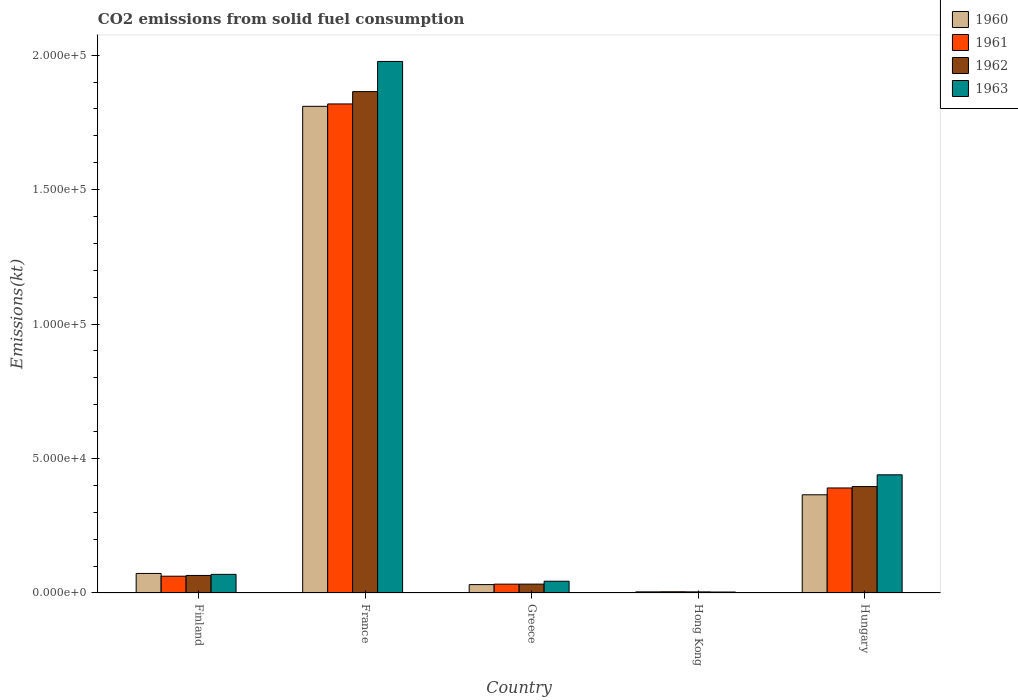How many different coloured bars are there?
Provide a short and direct response. 4. How many groups of bars are there?
Provide a succinct answer. 5. Are the number of bars per tick equal to the number of legend labels?
Make the answer very short. Yes. How many bars are there on the 1st tick from the left?
Your answer should be compact. 4. What is the amount of CO2 emitted in 1961 in Finland?
Ensure brevity in your answer.  6237.57. Across all countries, what is the maximum amount of CO2 emitted in 1960?
Offer a very short reply. 1.81e+05. Across all countries, what is the minimum amount of CO2 emitted in 1961?
Your answer should be very brief. 451.04. In which country was the amount of CO2 emitted in 1962 maximum?
Keep it short and to the point. France. In which country was the amount of CO2 emitted in 1962 minimum?
Your answer should be very brief. Hong Kong. What is the total amount of CO2 emitted in 1960 in the graph?
Offer a terse response. 2.28e+05. What is the difference between the amount of CO2 emitted in 1963 in Finland and that in Hungary?
Make the answer very short. -3.70e+04. What is the difference between the amount of CO2 emitted in 1960 in Greece and the amount of CO2 emitted in 1963 in Hong Kong?
Your answer should be very brief. 2761.25. What is the average amount of CO2 emitted in 1963 per country?
Give a very brief answer. 5.07e+04. What is the difference between the amount of CO2 emitted of/in 1963 and amount of CO2 emitted of/in 1960 in Greece?
Offer a very short reply. 1254.11. What is the ratio of the amount of CO2 emitted in 1963 in Hong Kong to that in Hungary?
Keep it short and to the point. 0.01. Is the amount of CO2 emitted in 1962 in France less than that in Hong Kong?
Provide a succinct answer. No. Is the difference between the amount of CO2 emitted in 1963 in France and Hungary greater than the difference between the amount of CO2 emitted in 1960 in France and Hungary?
Provide a succinct answer. Yes. What is the difference between the highest and the second highest amount of CO2 emitted in 1962?
Ensure brevity in your answer.  -1.47e+05. What is the difference between the highest and the lowest amount of CO2 emitted in 1962?
Offer a terse response. 1.86e+05. In how many countries, is the amount of CO2 emitted in 1961 greater than the average amount of CO2 emitted in 1961 taken over all countries?
Give a very brief answer. 1. What does the 1st bar from the left in Finland represents?
Keep it short and to the point. 1960. What does the 3rd bar from the right in Finland represents?
Provide a succinct answer. 1961. Is it the case that in every country, the sum of the amount of CO2 emitted in 1961 and amount of CO2 emitted in 1962 is greater than the amount of CO2 emitted in 1960?
Offer a very short reply. Yes. What is the difference between two consecutive major ticks on the Y-axis?
Give a very brief answer. 5.00e+04. Does the graph contain grids?
Your answer should be compact. No. How are the legend labels stacked?
Provide a short and direct response. Vertical. What is the title of the graph?
Your answer should be compact. CO2 emissions from solid fuel consumption. Does "1980" appear as one of the legend labels in the graph?
Ensure brevity in your answer.  No. What is the label or title of the X-axis?
Give a very brief answer. Country. What is the label or title of the Y-axis?
Ensure brevity in your answer.  Emissions(kt). What is the Emissions(kt) in 1960 in Finland?
Your answer should be very brief. 7267.99. What is the Emissions(kt) in 1961 in Finland?
Ensure brevity in your answer.  6237.57. What is the Emissions(kt) of 1962 in Finland?
Offer a very short reply. 6523.59. What is the Emissions(kt) of 1963 in Finland?
Your response must be concise. 6926.96. What is the Emissions(kt) in 1960 in France?
Ensure brevity in your answer.  1.81e+05. What is the Emissions(kt) in 1961 in France?
Ensure brevity in your answer.  1.82e+05. What is the Emissions(kt) in 1962 in France?
Make the answer very short. 1.86e+05. What is the Emissions(kt) in 1963 in France?
Give a very brief answer. 1.98e+05. What is the Emissions(kt) in 1960 in Greece?
Your response must be concise. 3120.62. What is the Emissions(kt) of 1961 in Greece?
Offer a terse response. 3285.63. What is the Emissions(kt) in 1962 in Greece?
Offer a terse response. 3300.3. What is the Emissions(kt) in 1963 in Greece?
Your answer should be compact. 4374.73. What is the Emissions(kt) in 1960 in Hong Kong?
Provide a succinct answer. 418.04. What is the Emissions(kt) in 1961 in Hong Kong?
Offer a terse response. 451.04. What is the Emissions(kt) of 1962 in Hong Kong?
Ensure brevity in your answer.  410.7. What is the Emissions(kt) in 1963 in Hong Kong?
Make the answer very short. 359.37. What is the Emissions(kt) of 1960 in Hungary?
Keep it short and to the point. 3.65e+04. What is the Emissions(kt) in 1961 in Hungary?
Provide a short and direct response. 3.91e+04. What is the Emissions(kt) of 1962 in Hungary?
Your response must be concise. 3.96e+04. What is the Emissions(kt) in 1963 in Hungary?
Your response must be concise. 4.39e+04. Across all countries, what is the maximum Emissions(kt) of 1960?
Provide a short and direct response. 1.81e+05. Across all countries, what is the maximum Emissions(kt) of 1961?
Offer a very short reply. 1.82e+05. Across all countries, what is the maximum Emissions(kt) of 1962?
Your answer should be very brief. 1.86e+05. Across all countries, what is the maximum Emissions(kt) in 1963?
Your answer should be compact. 1.98e+05. Across all countries, what is the minimum Emissions(kt) of 1960?
Offer a terse response. 418.04. Across all countries, what is the minimum Emissions(kt) in 1961?
Make the answer very short. 451.04. Across all countries, what is the minimum Emissions(kt) of 1962?
Give a very brief answer. 410.7. Across all countries, what is the minimum Emissions(kt) of 1963?
Provide a short and direct response. 359.37. What is the total Emissions(kt) of 1960 in the graph?
Make the answer very short. 2.28e+05. What is the total Emissions(kt) of 1961 in the graph?
Ensure brevity in your answer.  2.31e+05. What is the total Emissions(kt) in 1962 in the graph?
Offer a terse response. 2.36e+05. What is the total Emissions(kt) in 1963 in the graph?
Offer a terse response. 2.53e+05. What is the difference between the Emissions(kt) of 1960 in Finland and that in France?
Ensure brevity in your answer.  -1.74e+05. What is the difference between the Emissions(kt) of 1961 in Finland and that in France?
Offer a very short reply. -1.76e+05. What is the difference between the Emissions(kt) of 1962 in Finland and that in France?
Your answer should be very brief. -1.80e+05. What is the difference between the Emissions(kt) in 1963 in Finland and that in France?
Offer a very short reply. -1.91e+05. What is the difference between the Emissions(kt) of 1960 in Finland and that in Greece?
Provide a short and direct response. 4147.38. What is the difference between the Emissions(kt) in 1961 in Finland and that in Greece?
Ensure brevity in your answer.  2951.93. What is the difference between the Emissions(kt) in 1962 in Finland and that in Greece?
Your response must be concise. 3223.29. What is the difference between the Emissions(kt) of 1963 in Finland and that in Greece?
Offer a terse response. 2552.23. What is the difference between the Emissions(kt) of 1960 in Finland and that in Hong Kong?
Your response must be concise. 6849.96. What is the difference between the Emissions(kt) in 1961 in Finland and that in Hong Kong?
Your answer should be very brief. 5786.53. What is the difference between the Emissions(kt) in 1962 in Finland and that in Hong Kong?
Your answer should be compact. 6112.89. What is the difference between the Emissions(kt) in 1963 in Finland and that in Hong Kong?
Your answer should be very brief. 6567.6. What is the difference between the Emissions(kt) in 1960 in Finland and that in Hungary?
Offer a very short reply. -2.93e+04. What is the difference between the Emissions(kt) of 1961 in Finland and that in Hungary?
Provide a succinct answer. -3.28e+04. What is the difference between the Emissions(kt) of 1962 in Finland and that in Hungary?
Provide a short and direct response. -3.31e+04. What is the difference between the Emissions(kt) in 1963 in Finland and that in Hungary?
Provide a succinct answer. -3.70e+04. What is the difference between the Emissions(kt) in 1960 in France and that in Greece?
Make the answer very short. 1.78e+05. What is the difference between the Emissions(kt) of 1961 in France and that in Greece?
Make the answer very short. 1.79e+05. What is the difference between the Emissions(kt) of 1962 in France and that in Greece?
Keep it short and to the point. 1.83e+05. What is the difference between the Emissions(kt) of 1963 in France and that in Greece?
Ensure brevity in your answer.  1.93e+05. What is the difference between the Emissions(kt) in 1960 in France and that in Hong Kong?
Provide a short and direct response. 1.81e+05. What is the difference between the Emissions(kt) in 1961 in France and that in Hong Kong?
Your answer should be very brief. 1.81e+05. What is the difference between the Emissions(kt) of 1962 in France and that in Hong Kong?
Your response must be concise. 1.86e+05. What is the difference between the Emissions(kt) in 1963 in France and that in Hong Kong?
Your response must be concise. 1.97e+05. What is the difference between the Emissions(kt) in 1960 in France and that in Hungary?
Provide a short and direct response. 1.44e+05. What is the difference between the Emissions(kt) of 1961 in France and that in Hungary?
Ensure brevity in your answer.  1.43e+05. What is the difference between the Emissions(kt) of 1962 in France and that in Hungary?
Your answer should be very brief. 1.47e+05. What is the difference between the Emissions(kt) of 1963 in France and that in Hungary?
Give a very brief answer. 1.54e+05. What is the difference between the Emissions(kt) in 1960 in Greece and that in Hong Kong?
Give a very brief answer. 2702.58. What is the difference between the Emissions(kt) in 1961 in Greece and that in Hong Kong?
Give a very brief answer. 2834.59. What is the difference between the Emissions(kt) of 1962 in Greece and that in Hong Kong?
Offer a terse response. 2889.6. What is the difference between the Emissions(kt) of 1963 in Greece and that in Hong Kong?
Offer a terse response. 4015.36. What is the difference between the Emissions(kt) in 1960 in Greece and that in Hungary?
Offer a very short reply. -3.34e+04. What is the difference between the Emissions(kt) in 1961 in Greece and that in Hungary?
Offer a terse response. -3.58e+04. What is the difference between the Emissions(kt) in 1962 in Greece and that in Hungary?
Your answer should be very brief. -3.63e+04. What is the difference between the Emissions(kt) in 1963 in Greece and that in Hungary?
Give a very brief answer. -3.96e+04. What is the difference between the Emissions(kt) of 1960 in Hong Kong and that in Hungary?
Ensure brevity in your answer.  -3.61e+04. What is the difference between the Emissions(kt) in 1961 in Hong Kong and that in Hungary?
Provide a succinct answer. -3.86e+04. What is the difference between the Emissions(kt) of 1962 in Hong Kong and that in Hungary?
Your answer should be very brief. -3.92e+04. What is the difference between the Emissions(kt) of 1963 in Hong Kong and that in Hungary?
Give a very brief answer. -4.36e+04. What is the difference between the Emissions(kt) in 1960 in Finland and the Emissions(kt) in 1961 in France?
Provide a succinct answer. -1.75e+05. What is the difference between the Emissions(kt) in 1960 in Finland and the Emissions(kt) in 1962 in France?
Your answer should be very brief. -1.79e+05. What is the difference between the Emissions(kt) of 1960 in Finland and the Emissions(kt) of 1963 in France?
Provide a short and direct response. -1.90e+05. What is the difference between the Emissions(kt) in 1961 in Finland and the Emissions(kt) in 1962 in France?
Make the answer very short. -1.80e+05. What is the difference between the Emissions(kt) in 1961 in Finland and the Emissions(kt) in 1963 in France?
Give a very brief answer. -1.91e+05. What is the difference between the Emissions(kt) of 1962 in Finland and the Emissions(kt) of 1963 in France?
Provide a short and direct response. -1.91e+05. What is the difference between the Emissions(kt) of 1960 in Finland and the Emissions(kt) of 1961 in Greece?
Your answer should be very brief. 3982.36. What is the difference between the Emissions(kt) of 1960 in Finland and the Emissions(kt) of 1962 in Greece?
Give a very brief answer. 3967.69. What is the difference between the Emissions(kt) of 1960 in Finland and the Emissions(kt) of 1963 in Greece?
Your response must be concise. 2893.26. What is the difference between the Emissions(kt) of 1961 in Finland and the Emissions(kt) of 1962 in Greece?
Your answer should be compact. 2937.27. What is the difference between the Emissions(kt) in 1961 in Finland and the Emissions(kt) in 1963 in Greece?
Offer a very short reply. 1862.84. What is the difference between the Emissions(kt) of 1962 in Finland and the Emissions(kt) of 1963 in Greece?
Make the answer very short. 2148.86. What is the difference between the Emissions(kt) of 1960 in Finland and the Emissions(kt) of 1961 in Hong Kong?
Give a very brief answer. 6816.95. What is the difference between the Emissions(kt) in 1960 in Finland and the Emissions(kt) in 1962 in Hong Kong?
Your answer should be compact. 6857.29. What is the difference between the Emissions(kt) of 1960 in Finland and the Emissions(kt) of 1963 in Hong Kong?
Your answer should be very brief. 6908.63. What is the difference between the Emissions(kt) of 1961 in Finland and the Emissions(kt) of 1962 in Hong Kong?
Offer a terse response. 5826.86. What is the difference between the Emissions(kt) in 1961 in Finland and the Emissions(kt) in 1963 in Hong Kong?
Your answer should be compact. 5878.2. What is the difference between the Emissions(kt) of 1962 in Finland and the Emissions(kt) of 1963 in Hong Kong?
Offer a very short reply. 6164.23. What is the difference between the Emissions(kt) in 1960 in Finland and the Emissions(kt) in 1961 in Hungary?
Provide a succinct answer. -3.18e+04. What is the difference between the Emissions(kt) of 1960 in Finland and the Emissions(kt) of 1962 in Hungary?
Make the answer very short. -3.23e+04. What is the difference between the Emissions(kt) of 1960 in Finland and the Emissions(kt) of 1963 in Hungary?
Your answer should be very brief. -3.67e+04. What is the difference between the Emissions(kt) in 1961 in Finland and the Emissions(kt) in 1962 in Hungary?
Make the answer very short. -3.33e+04. What is the difference between the Emissions(kt) of 1961 in Finland and the Emissions(kt) of 1963 in Hungary?
Your answer should be very brief. -3.77e+04. What is the difference between the Emissions(kt) of 1962 in Finland and the Emissions(kt) of 1963 in Hungary?
Keep it short and to the point. -3.74e+04. What is the difference between the Emissions(kt) of 1960 in France and the Emissions(kt) of 1961 in Greece?
Offer a very short reply. 1.78e+05. What is the difference between the Emissions(kt) of 1960 in France and the Emissions(kt) of 1962 in Greece?
Offer a terse response. 1.78e+05. What is the difference between the Emissions(kt) of 1960 in France and the Emissions(kt) of 1963 in Greece?
Give a very brief answer. 1.77e+05. What is the difference between the Emissions(kt) of 1961 in France and the Emissions(kt) of 1962 in Greece?
Make the answer very short. 1.79e+05. What is the difference between the Emissions(kt) of 1961 in France and the Emissions(kt) of 1963 in Greece?
Make the answer very short. 1.78e+05. What is the difference between the Emissions(kt) of 1962 in France and the Emissions(kt) of 1963 in Greece?
Provide a short and direct response. 1.82e+05. What is the difference between the Emissions(kt) in 1960 in France and the Emissions(kt) in 1961 in Hong Kong?
Provide a short and direct response. 1.81e+05. What is the difference between the Emissions(kt) of 1960 in France and the Emissions(kt) of 1962 in Hong Kong?
Keep it short and to the point. 1.81e+05. What is the difference between the Emissions(kt) of 1960 in France and the Emissions(kt) of 1963 in Hong Kong?
Offer a very short reply. 1.81e+05. What is the difference between the Emissions(kt) in 1961 in France and the Emissions(kt) in 1962 in Hong Kong?
Your response must be concise. 1.81e+05. What is the difference between the Emissions(kt) of 1961 in France and the Emissions(kt) of 1963 in Hong Kong?
Your response must be concise. 1.82e+05. What is the difference between the Emissions(kt) of 1962 in France and the Emissions(kt) of 1963 in Hong Kong?
Offer a terse response. 1.86e+05. What is the difference between the Emissions(kt) in 1960 in France and the Emissions(kt) in 1961 in Hungary?
Ensure brevity in your answer.  1.42e+05. What is the difference between the Emissions(kt) in 1960 in France and the Emissions(kt) in 1962 in Hungary?
Give a very brief answer. 1.41e+05. What is the difference between the Emissions(kt) in 1960 in France and the Emissions(kt) in 1963 in Hungary?
Provide a short and direct response. 1.37e+05. What is the difference between the Emissions(kt) of 1961 in France and the Emissions(kt) of 1962 in Hungary?
Provide a succinct answer. 1.42e+05. What is the difference between the Emissions(kt) in 1961 in France and the Emissions(kt) in 1963 in Hungary?
Provide a succinct answer. 1.38e+05. What is the difference between the Emissions(kt) of 1962 in France and the Emissions(kt) of 1963 in Hungary?
Your answer should be very brief. 1.43e+05. What is the difference between the Emissions(kt) of 1960 in Greece and the Emissions(kt) of 1961 in Hong Kong?
Offer a very short reply. 2669.58. What is the difference between the Emissions(kt) of 1960 in Greece and the Emissions(kt) of 1962 in Hong Kong?
Provide a succinct answer. 2709.91. What is the difference between the Emissions(kt) of 1960 in Greece and the Emissions(kt) of 1963 in Hong Kong?
Give a very brief answer. 2761.25. What is the difference between the Emissions(kt) of 1961 in Greece and the Emissions(kt) of 1962 in Hong Kong?
Provide a succinct answer. 2874.93. What is the difference between the Emissions(kt) in 1961 in Greece and the Emissions(kt) in 1963 in Hong Kong?
Your answer should be very brief. 2926.27. What is the difference between the Emissions(kt) of 1962 in Greece and the Emissions(kt) of 1963 in Hong Kong?
Provide a short and direct response. 2940.93. What is the difference between the Emissions(kt) in 1960 in Greece and the Emissions(kt) in 1961 in Hungary?
Keep it short and to the point. -3.59e+04. What is the difference between the Emissions(kt) in 1960 in Greece and the Emissions(kt) in 1962 in Hungary?
Provide a short and direct response. -3.65e+04. What is the difference between the Emissions(kt) of 1960 in Greece and the Emissions(kt) of 1963 in Hungary?
Ensure brevity in your answer.  -4.08e+04. What is the difference between the Emissions(kt) in 1961 in Greece and the Emissions(kt) in 1962 in Hungary?
Keep it short and to the point. -3.63e+04. What is the difference between the Emissions(kt) of 1961 in Greece and the Emissions(kt) of 1963 in Hungary?
Provide a short and direct response. -4.07e+04. What is the difference between the Emissions(kt) of 1962 in Greece and the Emissions(kt) of 1963 in Hungary?
Your response must be concise. -4.06e+04. What is the difference between the Emissions(kt) in 1960 in Hong Kong and the Emissions(kt) in 1961 in Hungary?
Provide a succinct answer. -3.86e+04. What is the difference between the Emissions(kt) of 1960 in Hong Kong and the Emissions(kt) of 1962 in Hungary?
Make the answer very short. -3.92e+04. What is the difference between the Emissions(kt) in 1960 in Hong Kong and the Emissions(kt) in 1963 in Hungary?
Make the answer very short. -4.35e+04. What is the difference between the Emissions(kt) in 1961 in Hong Kong and the Emissions(kt) in 1962 in Hungary?
Ensure brevity in your answer.  -3.91e+04. What is the difference between the Emissions(kt) in 1961 in Hong Kong and the Emissions(kt) in 1963 in Hungary?
Offer a very short reply. -4.35e+04. What is the difference between the Emissions(kt) in 1962 in Hong Kong and the Emissions(kt) in 1963 in Hungary?
Provide a short and direct response. -4.35e+04. What is the average Emissions(kt) in 1960 per country?
Offer a terse response. 4.57e+04. What is the average Emissions(kt) of 1961 per country?
Your answer should be compact. 4.62e+04. What is the average Emissions(kt) of 1962 per country?
Ensure brevity in your answer.  4.73e+04. What is the average Emissions(kt) of 1963 per country?
Make the answer very short. 5.07e+04. What is the difference between the Emissions(kt) of 1960 and Emissions(kt) of 1961 in Finland?
Keep it short and to the point. 1030.43. What is the difference between the Emissions(kt) of 1960 and Emissions(kt) of 1962 in Finland?
Your answer should be compact. 744.4. What is the difference between the Emissions(kt) in 1960 and Emissions(kt) in 1963 in Finland?
Your answer should be very brief. 341.03. What is the difference between the Emissions(kt) of 1961 and Emissions(kt) of 1962 in Finland?
Give a very brief answer. -286.03. What is the difference between the Emissions(kt) of 1961 and Emissions(kt) of 1963 in Finland?
Keep it short and to the point. -689.4. What is the difference between the Emissions(kt) in 1962 and Emissions(kt) in 1963 in Finland?
Offer a very short reply. -403.37. What is the difference between the Emissions(kt) in 1960 and Emissions(kt) in 1961 in France?
Offer a very short reply. -887.41. What is the difference between the Emissions(kt) of 1960 and Emissions(kt) of 1962 in France?
Provide a short and direct response. -5471.16. What is the difference between the Emissions(kt) in 1960 and Emissions(kt) in 1963 in France?
Offer a very short reply. -1.67e+04. What is the difference between the Emissions(kt) of 1961 and Emissions(kt) of 1962 in France?
Make the answer very short. -4583.75. What is the difference between the Emissions(kt) of 1961 and Emissions(kt) of 1963 in France?
Your response must be concise. -1.58e+04. What is the difference between the Emissions(kt) in 1962 and Emissions(kt) in 1963 in France?
Offer a very short reply. -1.12e+04. What is the difference between the Emissions(kt) of 1960 and Emissions(kt) of 1961 in Greece?
Ensure brevity in your answer.  -165.01. What is the difference between the Emissions(kt) in 1960 and Emissions(kt) in 1962 in Greece?
Your answer should be very brief. -179.68. What is the difference between the Emissions(kt) of 1960 and Emissions(kt) of 1963 in Greece?
Offer a very short reply. -1254.11. What is the difference between the Emissions(kt) of 1961 and Emissions(kt) of 1962 in Greece?
Make the answer very short. -14.67. What is the difference between the Emissions(kt) of 1961 and Emissions(kt) of 1963 in Greece?
Ensure brevity in your answer.  -1089.1. What is the difference between the Emissions(kt) of 1962 and Emissions(kt) of 1963 in Greece?
Your answer should be compact. -1074.43. What is the difference between the Emissions(kt) in 1960 and Emissions(kt) in 1961 in Hong Kong?
Your response must be concise. -33. What is the difference between the Emissions(kt) in 1960 and Emissions(kt) in 1962 in Hong Kong?
Offer a very short reply. 7.33. What is the difference between the Emissions(kt) in 1960 and Emissions(kt) in 1963 in Hong Kong?
Make the answer very short. 58.67. What is the difference between the Emissions(kt) of 1961 and Emissions(kt) of 1962 in Hong Kong?
Your answer should be compact. 40.34. What is the difference between the Emissions(kt) in 1961 and Emissions(kt) in 1963 in Hong Kong?
Ensure brevity in your answer.  91.67. What is the difference between the Emissions(kt) of 1962 and Emissions(kt) of 1963 in Hong Kong?
Provide a succinct answer. 51.34. What is the difference between the Emissions(kt) of 1960 and Emissions(kt) of 1961 in Hungary?
Give a very brief answer. -2537.56. What is the difference between the Emissions(kt) of 1960 and Emissions(kt) of 1962 in Hungary?
Your answer should be compact. -3058.28. What is the difference between the Emissions(kt) of 1960 and Emissions(kt) of 1963 in Hungary?
Your answer should be very brief. -7429.34. What is the difference between the Emissions(kt) of 1961 and Emissions(kt) of 1962 in Hungary?
Provide a succinct answer. -520.71. What is the difference between the Emissions(kt) of 1961 and Emissions(kt) of 1963 in Hungary?
Keep it short and to the point. -4891.78. What is the difference between the Emissions(kt) of 1962 and Emissions(kt) of 1963 in Hungary?
Your response must be concise. -4371.06. What is the ratio of the Emissions(kt) in 1960 in Finland to that in France?
Your response must be concise. 0.04. What is the ratio of the Emissions(kt) in 1961 in Finland to that in France?
Your response must be concise. 0.03. What is the ratio of the Emissions(kt) in 1962 in Finland to that in France?
Offer a very short reply. 0.04. What is the ratio of the Emissions(kt) in 1963 in Finland to that in France?
Offer a terse response. 0.04. What is the ratio of the Emissions(kt) of 1960 in Finland to that in Greece?
Your response must be concise. 2.33. What is the ratio of the Emissions(kt) in 1961 in Finland to that in Greece?
Offer a very short reply. 1.9. What is the ratio of the Emissions(kt) of 1962 in Finland to that in Greece?
Offer a terse response. 1.98. What is the ratio of the Emissions(kt) in 1963 in Finland to that in Greece?
Provide a short and direct response. 1.58. What is the ratio of the Emissions(kt) of 1960 in Finland to that in Hong Kong?
Provide a succinct answer. 17.39. What is the ratio of the Emissions(kt) of 1961 in Finland to that in Hong Kong?
Your response must be concise. 13.83. What is the ratio of the Emissions(kt) in 1962 in Finland to that in Hong Kong?
Ensure brevity in your answer.  15.88. What is the ratio of the Emissions(kt) in 1963 in Finland to that in Hong Kong?
Offer a very short reply. 19.28. What is the ratio of the Emissions(kt) of 1960 in Finland to that in Hungary?
Make the answer very short. 0.2. What is the ratio of the Emissions(kt) in 1961 in Finland to that in Hungary?
Make the answer very short. 0.16. What is the ratio of the Emissions(kt) of 1962 in Finland to that in Hungary?
Provide a succinct answer. 0.16. What is the ratio of the Emissions(kt) of 1963 in Finland to that in Hungary?
Your answer should be compact. 0.16. What is the ratio of the Emissions(kt) of 1960 in France to that in Greece?
Your answer should be very brief. 58. What is the ratio of the Emissions(kt) of 1961 in France to that in Greece?
Make the answer very short. 55.35. What is the ratio of the Emissions(kt) in 1962 in France to that in Greece?
Ensure brevity in your answer.  56.5. What is the ratio of the Emissions(kt) in 1963 in France to that in Greece?
Ensure brevity in your answer.  45.19. What is the ratio of the Emissions(kt) in 1960 in France to that in Hong Kong?
Your answer should be very brief. 432.95. What is the ratio of the Emissions(kt) of 1961 in France to that in Hong Kong?
Ensure brevity in your answer.  403.24. What is the ratio of the Emissions(kt) of 1962 in France to that in Hong Kong?
Ensure brevity in your answer.  454. What is the ratio of the Emissions(kt) in 1963 in France to that in Hong Kong?
Provide a succinct answer. 550.07. What is the ratio of the Emissions(kt) in 1960 in France to that in Hungary?
Make the answer very short. 4.96. What is the ratio of the Emissions(kt) of 1961 in France to that in Hungary?
Give a very brief answer. 4.66. What is the ratio of the Emissions(kt) of 1962 in France to that in Hungary?
Your response must be concise. 4.71. What is the ratio of the Emissions(kt) of 1963 in France to that in Hungary?
Offer a very short reply. 4.5. What is the ratio of the Emissions(kt) of 1960 in Greece to that in Hong Kong?
Offer a terse response. 7.46. What is the ratio of the Emissions(kt) of 1961 in Greece to that in Hong Kong?
Offer a terse response. 7.28. What is the ratio of the Emissions(kt) in 1962 in Greece to that in Hong Kong?
Keep it short and to the point. 8.04. What is the ratio of the Emissions(kt) of 1963 in Greece to that in Hong Kong?
Offer a terse response. 12.17. What is the ratio of the Emissions(kt) of 1960 in Greece to that in Hungary?
Ensure brevity in your answer.  0.09. What is the ratio of the Emissions(kt) in 1961 in Greece to that in Hungary?
Give a very brief answer. 0.08. What is the ratio of the Emissions(kt) in 1962 in Greece to that in Hungary?
Your answer should be compact. 0.08. What is the ratio of the Emissions(kt) in 1963 in Greece to that in Hungary?
Provide a succinct answer. 0.1. What is the ratio of the Emissions(kt) in 1960 in Hong Kong to that in Hungary?
Ensure brevity in your answer.  0.01. What is the ratio of the Emissions(kt) in 1961 in Hong Kong to that in Hungary?
Keep it short and to the point. 0.01. What is the ratio of the Emissions(kt) in 1962 in Hong Kong to that in Hungary?
Give a very brief answer. 0.01. What is the ratio of the Emissions(kt) in 1963 in Hong Kong to that in Hungary?
Your answer should be compact. 0.01. What is the difference between the highest and the second highest Emissions(kt) in 1960?
Give a very brief answer. 1.44e+05. What is the difference between the highest and the second highest Emissions(kt) in 1961?
Give a very brief answer. 1.43e+05. What is the difference between the highest and the second highest Emissions(kt) of 1962?
Provide a short and direct response. 1.47e+05. What is the difference between the highest and the second highest Emissions(kt) in 1963?
Offer a very short reply. 1.54e+05. What is the difference between the highest and the lowest Emissions(kt) in 1960?
Provide a succinct answer. 1.81e+05. What is the difference between the highest and the lowest Emissions(kt) in 1961?
Offer a terse response. 1.81e+05. What is the difference between the highest and the lowest Emissions(kt) of 1962?
Give a very brief answer. 1.86e+05. What is the difference between the highest and the lowest Emissions(kt) of 1963?
Your answer should be compact. 1.97e+05. 